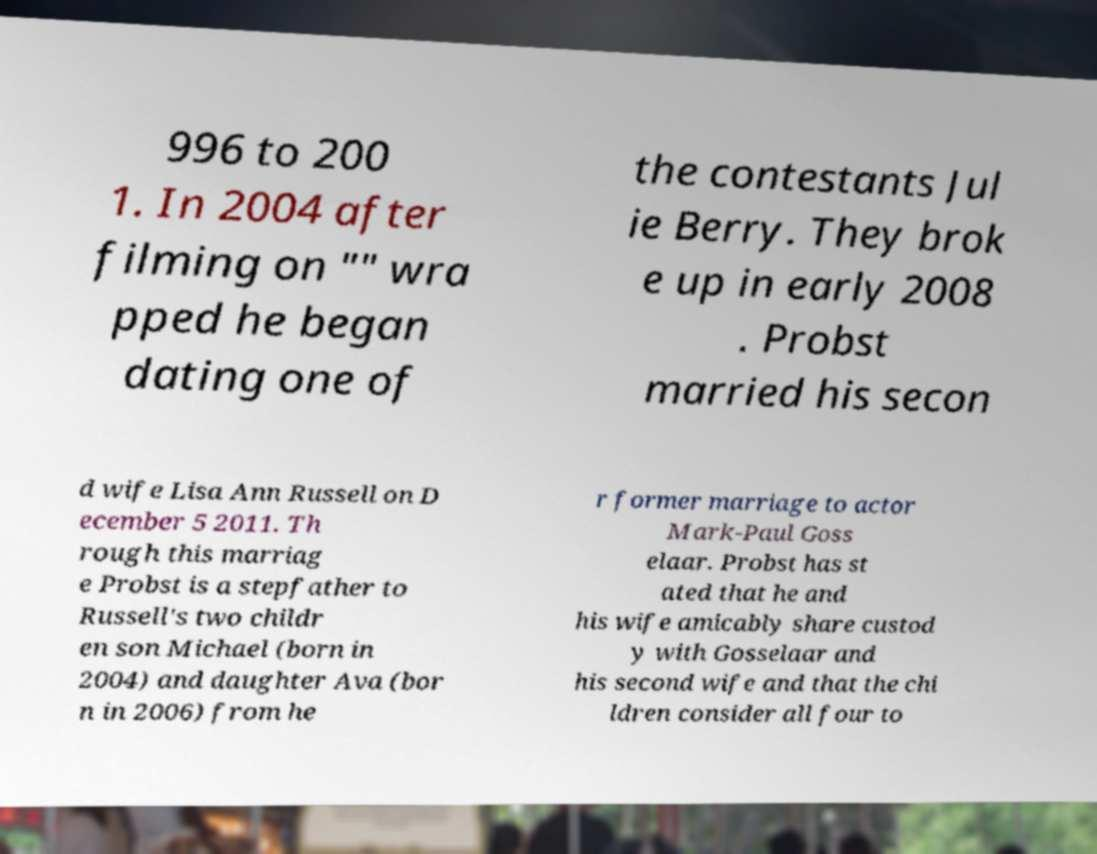What messages or text are displayed in this image? I need them in a readable, typed format. 996 to 200 1. In 2004 after filming on "" wra pped he began dating one of the contestants Jul ie Berry. They brok e up in early 2008 . Probst married his secon d wife Lisa Ann Russell on D ecember 5 2011. Th rough this marriag e Probst is a stepfather to Russell's two childr en son Michael (born in 2004) and daughter Ava (bor n in 2006) from he r former marriage to actor Mark-Paul Goss elaar. Probst has st ated that he and his wife amicably share custod y with Gosselaar and his second wife and that the chi ldren consider all four to 